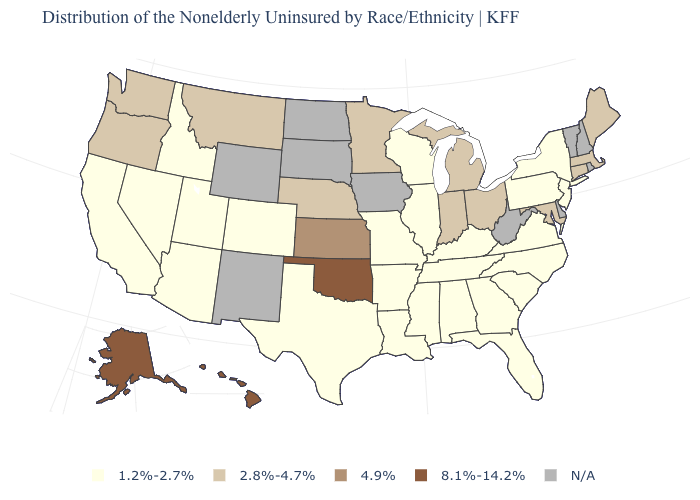What is the highest value in states that border Ohio?
Concise answer only. 2.8%-4.7%. Does the first symbol in the legend represent the smallest category?
Concise answer only. Yes. Name the states that have a value in the range 1.2%-2.7%?
Concise answer only. Alabama, Arizona, Arkansas, California, Colorado, Florida, Georgia, Idaho, Illinois, Kentucky, Louisiana, Mississippi, Missouri, Nevada, New Jersey, New York, North Carolina, Pennsylvania, South Carolina, Tennessee, Texas, Utah, Virginia, Wisconsin. What is the value of Kansas?
Short answer required. 4.9%. Does Oklahoma have the highest value in the USA?
Short answer required. Yes. Name the states that have a value in the range 2.8%-4.7%?
Give a very brief answer. Connecticut, Indiana, Maine, Maryland, Massachusetts, Michigan, Minnesota, Montana, Nebraska, Ohio, Oregon, Washington. Does Illinois have the lowest value in the USA?
Write a very short answer. Yes. How many symbols are there in the legend?
Short answer required. 5. Name the states that have a value in the range 1.2%-2.7%?
Write a very short answer. Alabama, Arizona, Arkansas, California, Colorado, Florida, Georgia, Idaho, Illinois, Kentucky, Louisiana, Mississippi, Missouri, Nevada, New Jersey, New York, North Carolina, Pennsylvania, South Carolina, Tennessee, Texas, Utah, Virginia, Wisconsin. Among the states that border Utah , which have the highest value?
Write a very short answer. Arizona, Colorado, Idaho, Nevada. What is the value of Rhode Island?
Keep it brief. N/A. Name the states that have a value in the range 8.1%-14.2%?
Be succinct. Alaska, Hawaii, Oklahoma. What is the value of Nevada?
Keep it brief. 1.2%-2.7%. 